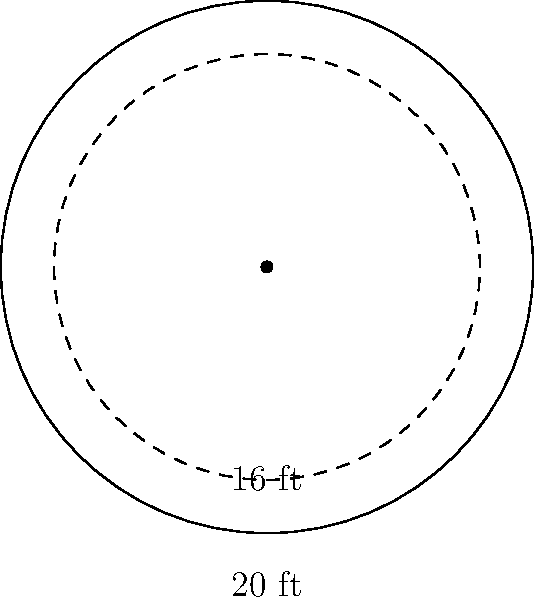A circular group therapy room has a diameter of 20 feet. The therapist wants to ensure a comfortable space for each client, allowing a 4-foot radius around each person. What is the maximum number of clients that can be accommodated in this room while maintaining appropriate personal space? To solve this problem, we need to follow these steps:

1. Calculate the area of the entire room:
   - Radius of the room: $r = 20/2 = 10$ feet
   - Area of the room: $A = \pi r^2 = \pi (10)^2 = 100\pi$ square feet

2. Calculate the area needed for each client:
   - Each client needs a 4-foot radius of personal space
   - Area per client: $A_{client} = \pi r^2 = \pi (4)^2 = 16\pi$ square feet

3. Calculate the number of clients that can fit:
   - Number of clients = Area of room / Area per client
   - $N = \frac{100\pi}{16\pi} = \frac{100}{16} = 6.25$

4. Round down to the nearest whole number, as we can't have a fraction of a person:
   - Maximum number of clients = 6

This arrangement ensures that each client has their own 4-foot radius of personal space within the 20-foot diameter room.
Answer: 6 clients 